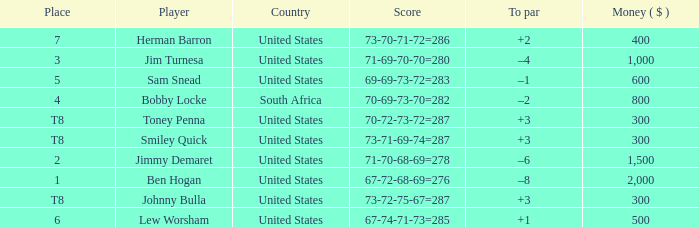What is the Score of the game of the Player in Place 4? 70-69-73-70=282. 